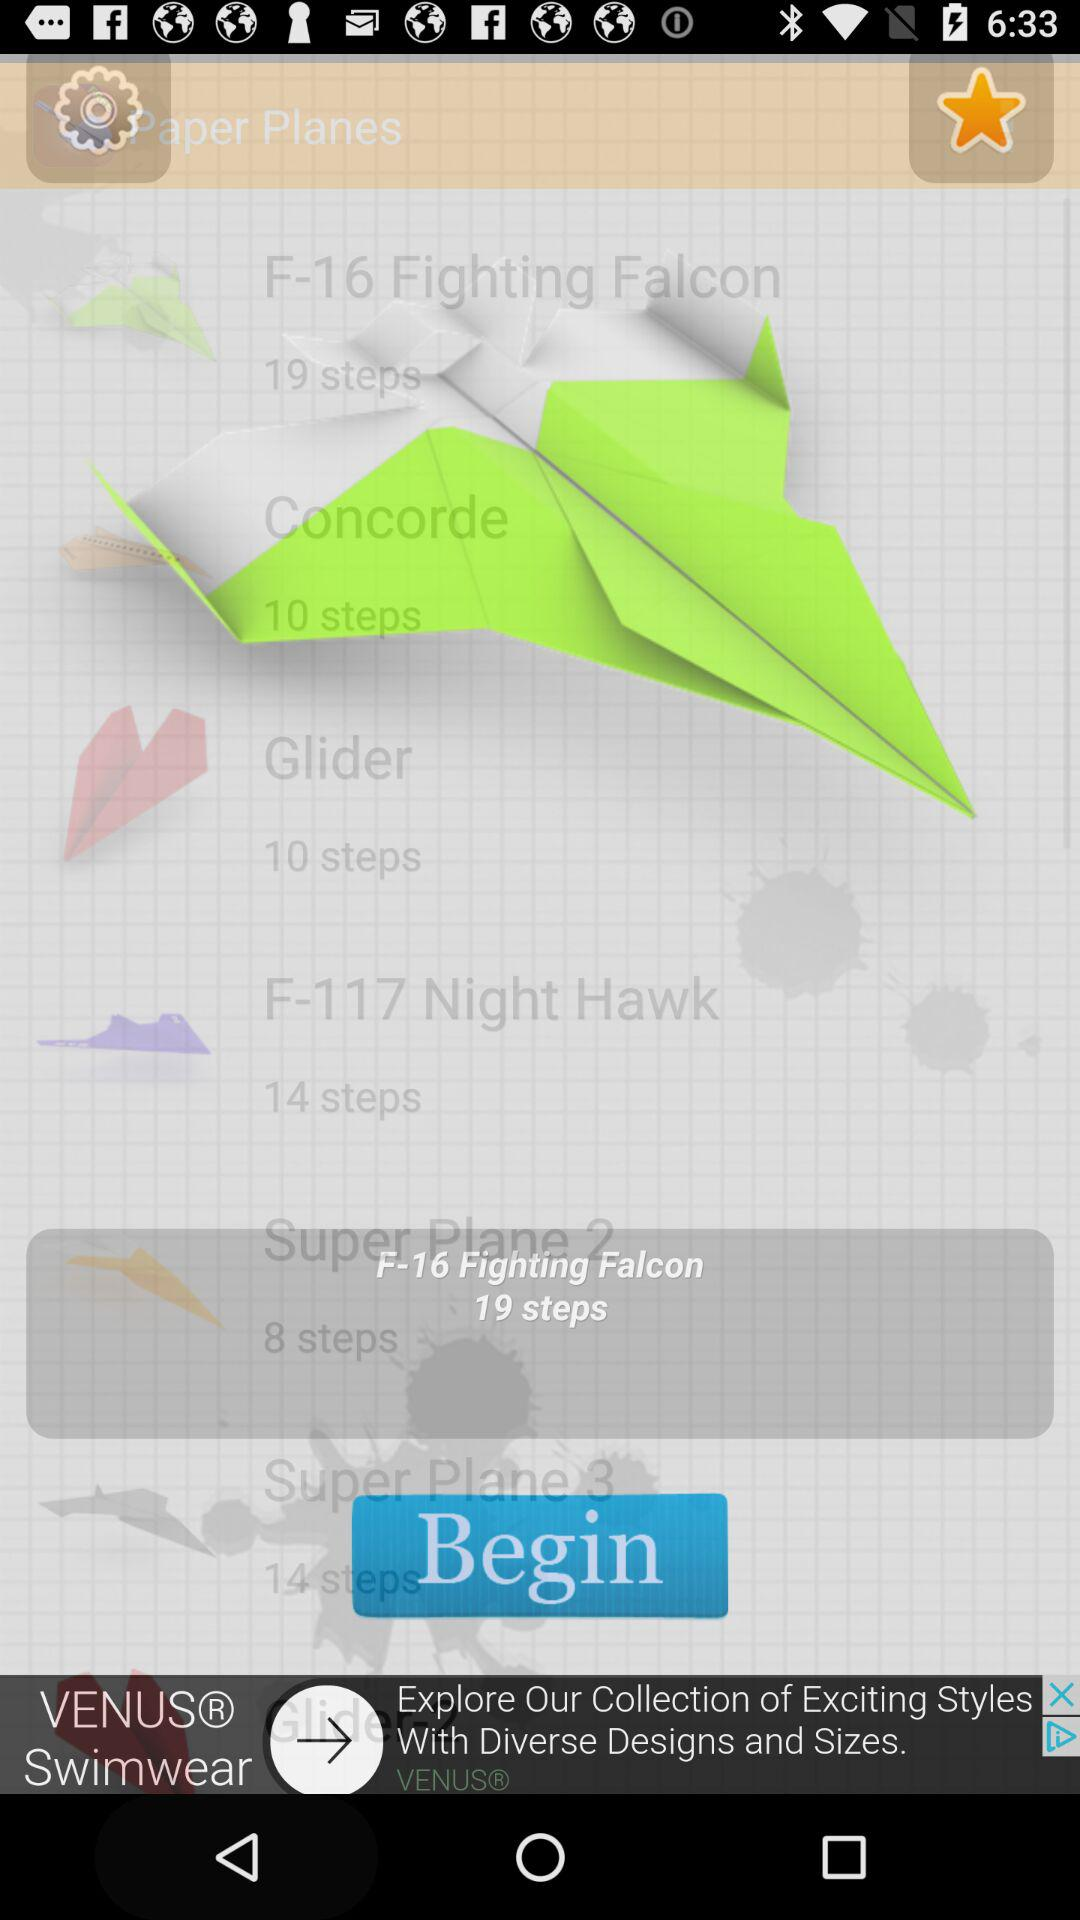How many planes are there with more than 10 steps?
Answer the question using a single word or phrase. 3 